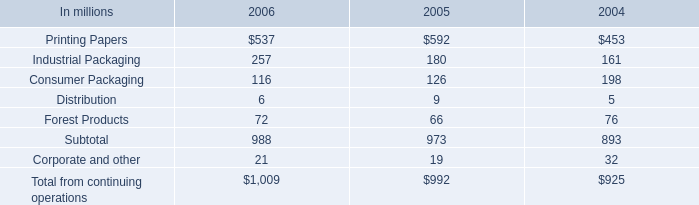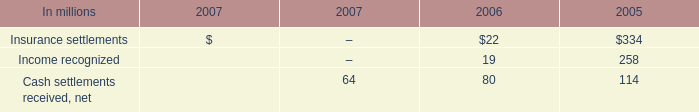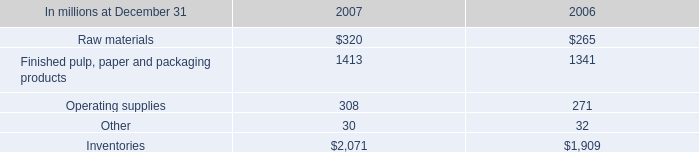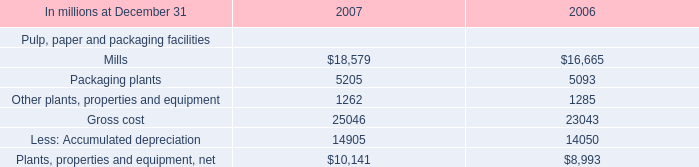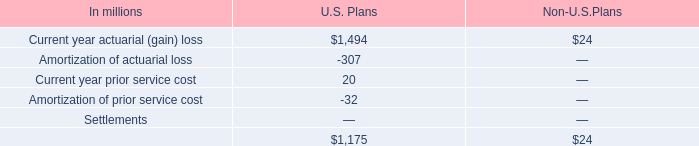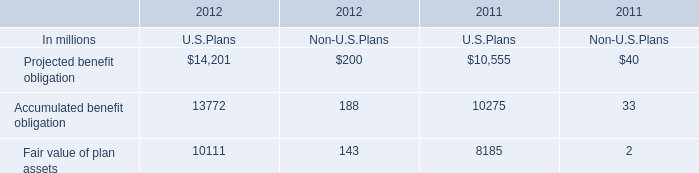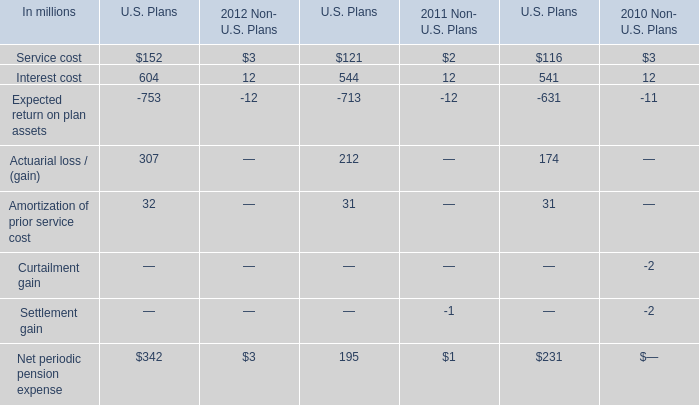What's the sum of all Accumulated benefit obligation that are positive in 2012? (in million) 
Computations: (13772 + 188)
Answer: 13960.0. 